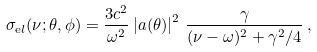<formula> <loc_0><loc_0><loc_500><loc_500>\sigma _ { \mathrm e l } ( \nu ; \theta , \phi ) = \frac { 3 c ^ { 2 } } { \omega ^ { 2 } } \left | a ( \theta ) \right | ^ { 2 } \, \frac { \gamma } { ( \nu - \omega ) ^ { 2 } + \gamma ^ { 2 } / 4 } \, ,</formula> 